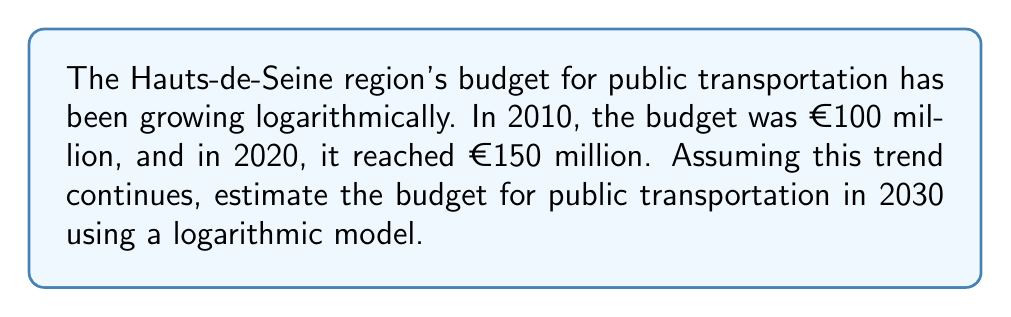Can you answer this question? 1) Let's define our logarithmic model as:
   $y = a \ln(x) + b$, where $y$ is the budget in millions of euros and $x$ is the number of years since 2010.

2) We have two known points: (0, 100) and (10, 150). Let's plug these into our equation:
   100 = $a \ln(1) + b$
   150 = $a \ln(11) + b$

3) From the first equation, since $\ln(1) = 0$, we get:
   $b = 100$

4) Substituting this into the second equation:
   150 = $a \ln(11) + 100$
   50 = $a \ln(11)$
   $a = \frac{50}{\ln(11)} \approx 21.61$

5) Our model is now:
   $y = 21.61 \ln(x) + 100$

6) To estimate the budget for 2030, we calculate for $x = 20$ (20 years after 2010):
   $y = 21.61 \ln(20) + 100$
   $y = 21.61 * 2.9957 + 100$
   $y \approx 164.72$
Answer: €164.72 million 